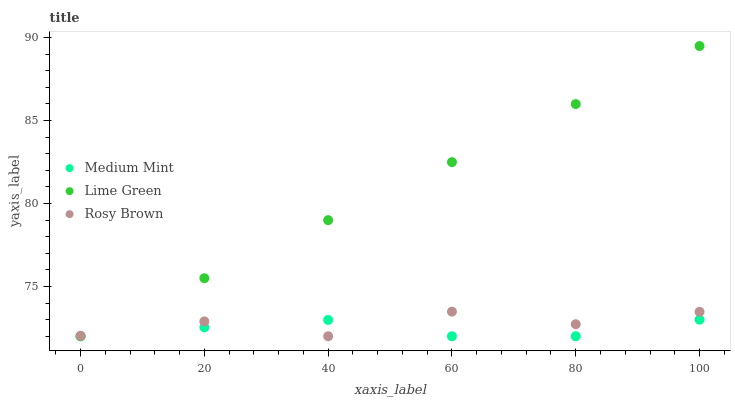Does Medium Mint have the minimum area under the curve?
Answer yes or no. Yes. Does Lime Green have the maximum area under the curve?
Answer yes or no. Yes. Does Rosy Brown have the minimum area under the curve?
Answer yes or no. No. Does Rosy Brown have the maximum area under the curve?
Answer yes or no. No. Is Lime Green the smoothest?
Answer yes or no. Yes. Is Rosy Brown the roughest?
Answer yes or no. Yes. Is Rosy Brown the smoothest?
Answer yes or no. No. Is Lime Green the roughest?
Answer yes or no. No. Does Medium Mint have the lowest value?
Answer yes or no. Yes. Does Lime Green have the highest value?
Answer yes or no. Yes. Does Rosy Brown have the highest value?
Answer yes or no. No. Does Rosy Brown intersect Medium Mint?
Answer yes or no. Yes. Is Rosy Brown less than Medium Mint?
Answer yes or no. No. Is Rosy Brown greater than Medium Mint?
Answer yes or no. No. 